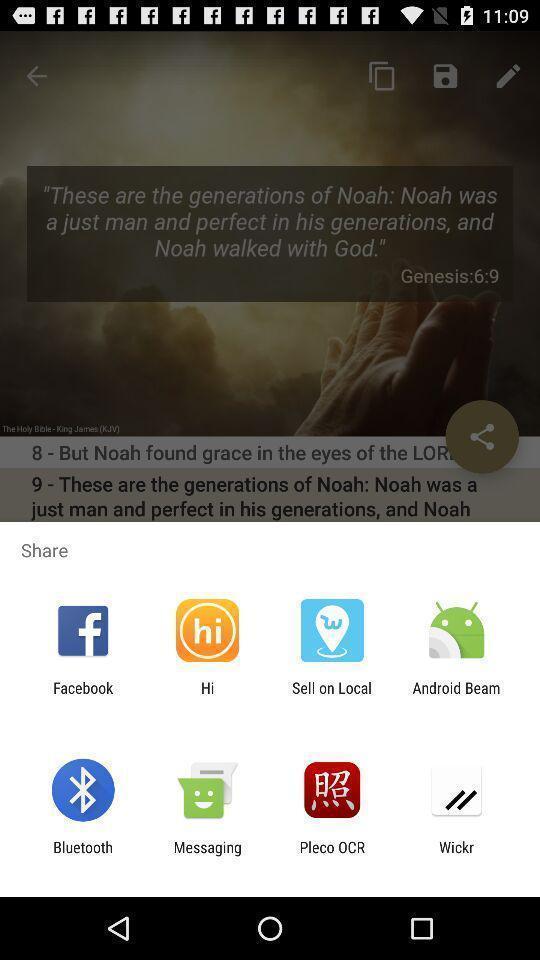Describe the key features of this screenshot. Pop-up showing various share options. 